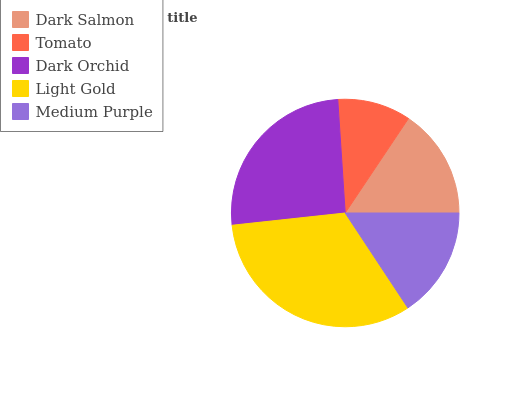Is Tomato the minimum?
Answer yes or no. Yes. Is Light Gold the maximum?
Answer yes or no. Yes. Is Dark Orchid the minimum?
Answer yes or no. No. Is Dark Orchid the maximum?
Answer yes or no. No. Is Dark Orchid greater than Tomato?
Answer yes or no. Yes. Is Tomato less than Dark Orchid?
Answer yes or no. Yes. Is Tomato greater than Dark Orchid?
Answer yes or no. No. Is Dark Orchid less than Tomato?
Answer yes or no. No. Is Medium Purple the high median?
Answer yes or no. Yes. Is Medium Purple the low median?
Answer yes or no. Yes. Is Light Gold the high median?
Answer yes or no. No. Is Light Gold the low median?
Answer yes or no. No. 